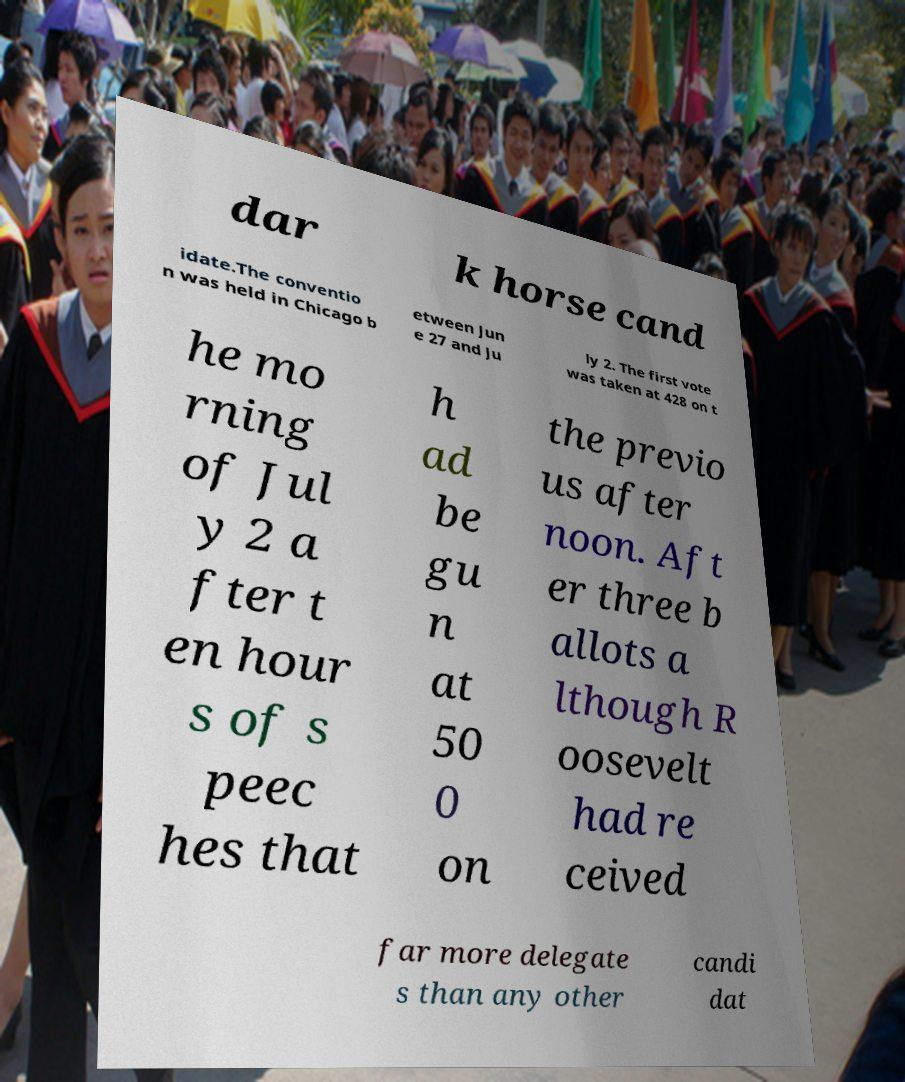What messages or text are displayed in this image? I need them in a readable, typed format. dar k horse cand idate.The conventio n was held in Chicago b etween Jun e 27 and Ju ly 2. The first vote was taken at 428 on t he mo rning of Jul y 2 a fter t en hour s of s peec hes that h ad be gu n at 50 0 on the previo us after noon. Aft er three b allots a lthough R oosevelt had re ceived far more delegate s than any other candi dat 